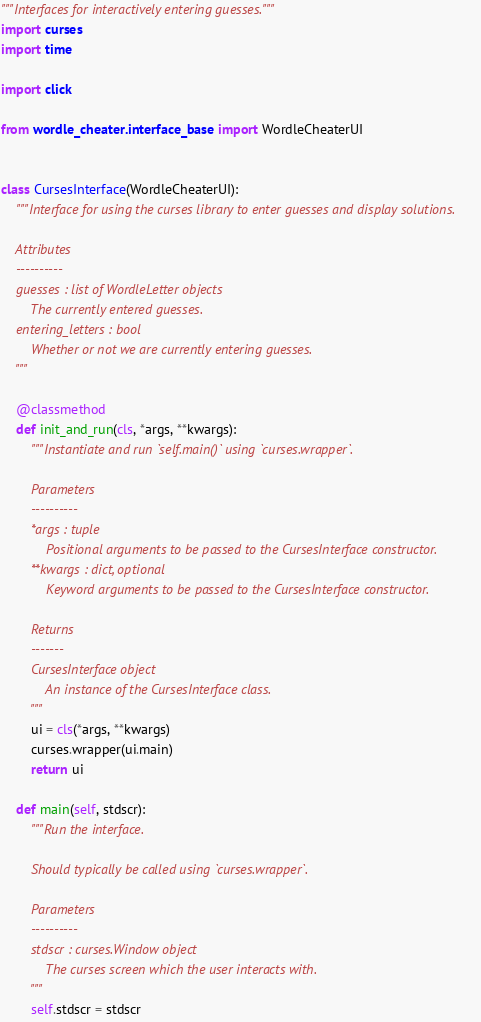Convert code to text. <code><loc_0><loc_0><loc_500><loc_500><_Python_>"""Interfaces for interactively entering guesses."""
import curses
import time

import click

from wordle_cheater.interface_base import WordleCheaterUI


class CursesInterface(WordleCheaterUI):
    """Interface for using the curses library to enter guesses and display solutions.

    Attributes
    ----------
    guesses : list of WordleLetter objects
        The currently entered guesses.
    entering_letters : bool
        Whether or not we are currently entering guesses.
    """

    @classmethod
    def init_and_run(cls, *args, **kwargs):
        """Instantiate and run `self.main()` using `curses.wrapper`.

        Parameters
        ----------
        *args : tuple
            Positional arguments to be passed to the CursesInterface constructor.
        **kwargs : dict, optional
            Keyword arguments to be passed to the CursesInterface constructor.

        Returns
        -------
        CursesInterface object
            An instance of the CursesInterface class.
        """
        ui = cls(*args, **kwargs)
        curses.wrapper(ui.main)
        return ui

    def main(self, stdscr):
        """Run the interface.

        Should typically be called using `curses.wrapper`.

        Parameters
        ----------
        stdscr : curses.Window object
            The curses screen which the user interacts with.
        """
        self.stdscr = stdscr</code> 